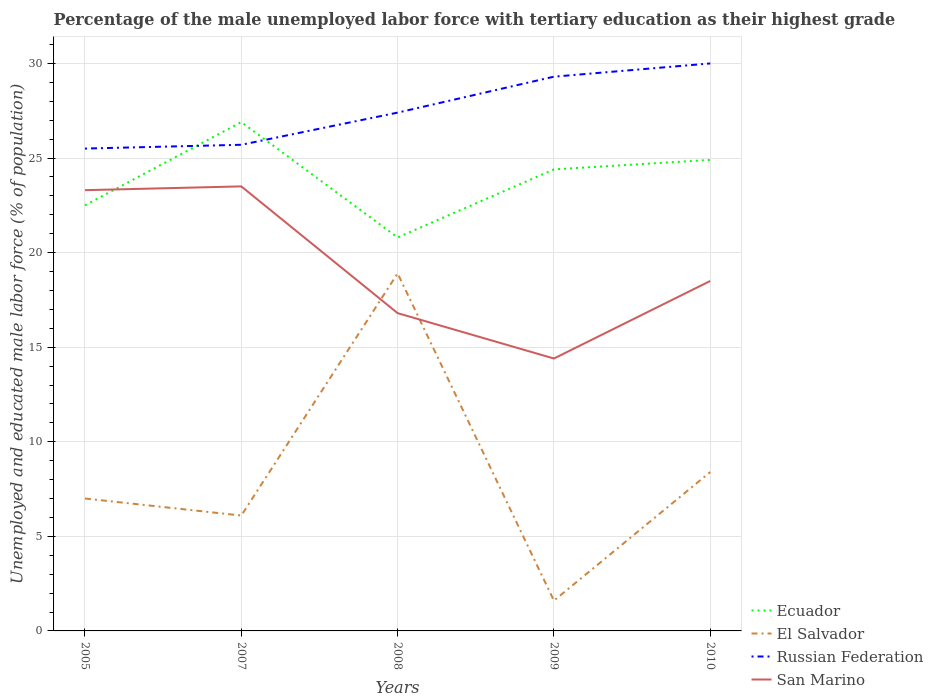How many different coloured lines are there?
Give a very brief answer. 4. Is the number of lines equal to the number of legend labels?
Your answer should be compact. Yes. Across all years, what is the maximum percentage of the unemployed male labor force with tertiary education in San Marino?
Your answer should be very brief. 14.4. In which year was the percentage of the unemployed male labor force with tertiary education in San Marino maximum?
Ensure brevity in your answer.  2009. What is the total percentage of the unemployed male labor force with tertiary education in El Salvador in the graph?
Offer a very short reply. 0.9. What is the difference between the highest and the second highest percentage of the unemployed male labor force with tertiary education in San Marino?
Ensure brevity in your answer.  9.1. What is the difference between the highest and the lowest percentage of the unemployed male labor force with tertiary education in Russian Federation?
Give a very brief answer. 2. Is the percentage of the unemployed male labor force with tertiary education in Ecuador strictly greater than the percentage of the unemployed male labor force with tertiary education in El Salvador over the years?
Your answer should be very brief. No. How many years are there in the graph?
Provide a short and direct response. 5. What is the difference between two consecutive major ticks on the Y-axis?
Make the answer very short. 5. Are the values on the major ticks of Y-axis written in scientific E-notation?
Offer a very short reply. No. What is the title of the graph?
Your answer should be compact. Percentage of the male unemployed labor force with tertiary education as their highest grade. What is the label or title of the Y-axis?
Provide a short and direct response. Unemployed and educated male labor force (% of population). What is the Unemployed and educated male labor force (% of population) in Russian Federation in 2005?
Your answer should be compact. 25.5. What is the Unemployed and educated male labor force (% of population) of San Marino in 2005?
Provide a short and direct response. 23.3. What is the Unemployed and educated male labor force (% of population) in Ecuador in 2007?
Your response must be concise. 26.9. What is the Unemployed and educated male labor force (% of population) in El Salvador in 2007?
Ensure brevity in your answer.  6.1. What is the Unemployed and educated male labor force (% of population) of Russian Federation in 2007?
Your response must be concise. 25.7. What is the Unemployed and educated male labor force (% of population) of Ecuador in 2008?
Give a very brief answer. 20.8. What is the Unemployed and educated male labor force (% of population) in El Salvador in 2008?
Offer a terse response. 18.9. What is the Unemployed and educated male labor force (% of population) in Russian Federation in 2008?
Keep it short and to the point. 27.4. What is the Unemployed and educated male labor force (% of population) in San Marino in 2008?
Your answer should be compact. 16.8. What is the Unemployed and educated male labor force (% of population) in Ecuador in 2009?
Provide a succinct answer. 24.4. What is the Unemployed and educated male labor force (% of population) of El Salvador in 2009?
Offer a very short reply. 1.6. What is the Unemployed and educated male labor force (% of population) of Russian Federation in 2009?
Offer a terse response. 29.3. What is the Unemployed and educated male labor force (% of population) of San Marino in 2009?
Offer a terse response. 14.4. What is the Unemployed and educated male labor force (% of population) of Ecuador in 2010?
Provide a short and direct response. 24.9. What is the Unemployed and educated male labor force (% of population) of El Salvador in 2010?
Your answer should be very brief. 8.4. What is the Unemployed and educated male labor force (% of population) in Russian Federation in 2010?
Give a very brief answer. 30. What is the Unemployed and educated male labor force (% of population) of San Marino in 2010?
Offer a terse response. 18.5. Across all years, what is the maximum Unemployed and educated male labor force (% of population) of Ecuador?
Your answer should be compact. 26.9. Across all years, what is the maximum Unemployed and educated male labor force (% of population) in El Salvador?
Offer a terse response. 18.9. Across all years, what is the minimum Unemployed and educated male labor force (% of population) of Ecuador?
Offer a terse response. 20.8. Across all years, what is the minimum Unemployed and educated male labor force (% of population) of El Salvador?
Offer a very short reply. 1.6. Across all years, what is the minimum Unemployed and educated male labor force (% of population) of San Marino?
Your answer should be very brief. 14.4. What is the total Unemployed and educated male labor force (% of population) of Ecuador in the graph?
Provide a succinct answer. 119.5. What is the total Unemployed and educated male labor force (% of population) in El Salvador in the graph?
Keep it short and to the point. 42. What is the total Unemployed and educated male labor force (% of population) of Russian Federation in the graph?
Keep it short and to the point. 137.9. What is the total Unemployed and educated male labor force (% of population) of San Marino in the graph?
Your answer should be compact. 96.5. What is the difference between the Unemployed and educated male labor force (% of population) of Ecuador in 2005 and that in 2008?
Provide a short and direct response. 1.7. What is the difference between the Unemployed and educated male labor force (% of population) of El Salvador in 2005 and that in 2008?
Offer a terse response. -11.9. What is the difference between the Unemployed and educated male labor force (% of population) in El Salvador in 2005 and that in 2009?
Provide a short and direct response. 5.4. What is the difference between the Unemployed and educated male labor force (% of population) in Russian Federation in 2005 and that in 2009?
Offer a very short reply. -3.8. What is the difference between the Unemployed and educated male labor force (% of population) in San Marino in 2005 and that in 2009?
Your response must be concise. 8.9. What is the difference between the Unemployed and educated male labor force (% of population) in Ecuador in 2005 and that in 2010?
Ensure brevity in your answer.  -2.4. What is the difference between the Unemployed and educated male labor force (% of population) in Russian Federation in 2005 and that in 2010?
Provide a short and direct response. -4.5. What is the difference between the Unemployed and educated male labor force (% of population) in Ecuador in 2007 and that in 2008?
Your answer should be very brief. 6.1. What is the difference between the Unemployed and educated male labor force (% of population) of El Salvador in 2007 and that in 2008?
Keep it short and to the point. -12.8. What is the difference between the Unemployed and educated male labor force (% of population) in San Marino in 2007 and that in 2008?
Provide a succinct answer. 6.7. What is the difference between the Unemployed and educated male labor force (% of population) of Ecuador in 2007 and that in 2009?
Your response must be concise. 2.5. What is the difference between the Unemployed and educated male labor force (% of population) of El Salvador in 2007 and that in 2009?
Keep it short and to the point. 4.5. What is the difference between the Unemployed and educated male labor force (% of population) of Russian Federation in 2007 and that in 2009?
Keep it short and to the point. -3.6. What is the difference between the Unemployed and educated male labor force (% of population) of Ecuador in 2007 and that in 2010?
Ensure brevity in your answer.  2. What is the difference between the Unemployed and educated male labor force (% of population) in El Salvador in 2007 and that in 2010?
Provide a short and direct response. -2.3. What is the difference between the Unemployed and educated male labor force (% of population) in Russian Federation in 2007 and that in 2010?
Give a very brief answer. -4.3. What is the difference between the Unemployed and educated male labor force (% of population) of San Marino in 2007 and that in 2010?
Offer a terse response. 5. What is the difference between the Unemployed and educated male labor force (% of population) of El Salvador in 2008 and that in 2009?
Provide a short and direct response. 17.3. What is the difference between the Unemployed and educated male labor force (% of population) in Russian Federation in 2008 and that in 2009?
Offer a terse response. -1.9. What is the difference between the Unemployed and educated male labor force (% of population) in San Marino in 2008 and that in 2009?
Give a very brief answer. 2.4. What is the difference between the Unemployed and educated male labor force (% of population) of Ecuador in 2008 and that in 2010?
Keep it short and to the point. -4.1. What is the difference between the Unemployed and educated male labor force (% of population) in San Marino in 2008 and that in 2010?
Give a very brief answer. -1.7. What is the difference between the Unemployed and educated male labor force (% of population) in San Marino in 2009 and that in 2010?
Provide a succinct answer. -4.1. What is the difference between the Unemployed and educated male labor force (% of population) of Ecuador in 2005 and the Unemployed and educated male labor force (% of population) of Russian Federation in 2007?
Ensure brevity in your answer.  -3.2. What is the difference between the Unemployed and educated male labor force (% of population) in Ecuador in 2005 and the Unemployed and educated male labor force (% of population) in San Marino in 2007?
Ensure brevity in your answer.  -1. What is the difference between the Unemployed and educated male labor force (% of population) of El Salvador in 2005 and the Unemployed and educated male labor force (% of population) of Russian Federation in 2007?
Offer a terse response. -18.7. What is the difference between the Unemployed and educated male labor force (% of population) in El Salvador in 2005 and the Unemployed and educated male labor force (% of population) in San Marino in 2007?
Provide a succinct answer. -16.5. What is the difference between the Unemployed and educated male labor force (% of population) of Ecuador in 2005 and the Unemployed and educated male labor force (% of population) of El Salvador in 2008?
Give a very brief answer. 3.6. What is the difference between the Unemployed and educated male labor force (% of population) in Ecuador in 2005 and the Unemployed and educated male labor force (% of population) in San Marino in 2008?
Provide a succinct answer. 5.7. What is the difference between the Unemployed and educated male labor force (% of population) of El Salvador in 2005 and the Unemployed and educated male labor force (% of population) of Russian Federation in 2008?
Make the answer very short. -20.4. What is the difference between the Unemployed and educated male labor force (% of population) in El Salvador in 2005 and the Unemployed and educated male labor force (% of population) in San Marino in 2008?
Your answer should be very brief. -9.8. What is the difference between the Unemployed and educated male labor force (% of population) in Russian Federation in 2005 and the Unemployed and educated male labor force (% of population) in San Marino in 2008?
Your response must be concise. 8.7. What is the difference between the Unemployed and educated male labor force (% of population) in Ecuador in 2005 and the Unemployed and educated male labor force (% of population) in El Salvador in 2009?
Give a very brief answer. 20.9. What is the difference between the Unemployed and educated male labor force (% of population) in El Salvador in 2005 and the Unemployed and educated male labor force (% of population) in Russian Federation in 2009?
Make the answer very short. -22.3. What is the difference between the Unemployed and educated male labor force (% of population) of Ecuador in 2005 and the Unemployed and educated male labor force (% of population) of El Salvador in 2010?
Your answer should be compact. 14.1. What is the difference between the Unemployed and educated male labor force (% of population) in El Salvador in 2005 and the Unemployed and educated male labor force (% of population) in San Marino in 2010?
Make the answer very short. -11.5. What is the difference between the Unemployed and educated male labor force (% of population) of Russian Federation in 2005 and the Unemployed and educated male labor force (% of population) of San Marino in 2010?
Offer a very short reply. 7. What is the difference between the Unemployed and educated male labor force (% of population) in Ecuador in 2007 and the Unemployed and educated male labor force (% of population) in San Marino in 2008?
Make the answer very short. 10.1. What is the difference between the Unemployed and educated male labor force (% of population) of El Salvador in 2007 and the Unemployed and educated male labor force (% of population) of Russian Federation in 2008?
Provide a short and direct response. -21.3. What is the difference between the Unemployed and educated male labor force (% of population) in Russian Federation in 2007 and the Unemployed and educated male labor force (% of population) in San Marino in 2008?
Give a very brief answer. 8.9. What is the difference between the Unemployed and educated male labor force (% of population) of Ecuador in 2007 and the Unemployed and educated male labor force (% of population) of El Salvador in 2009?
Ensure brevity in your answer.  25.3. What is the difference between the Unemployed and educated male labor force (% of population) of Ecuador in 2007 and the Unemployed and educated male labor force (% of population) of Russian Federation in 2009?
Offer a terse response. -2.4. What is the difference between the Unemployed and educated male labor force (% of population) of El Salvador in 2007 and the Unemployed and educated male labor force (% of population) of Russian Federation in 2009?
Keep it short and to the point. -23.2. What is the difference between the Unemployed and educated male labor force (% of population) of Ecuador in 2007 and the Unemployed and educated male labor force (% of population) of San Marino in 2010?
Your answer should be very brief. 8.4. What is the difference between the Unemployed and educated male labor force (% of population) in El Salvador in 2007 and the Unemployed and educated male labor force (% of population) in Russian Federation in 2010?
Your response must be concise. -23.9. What is the difference between the Unemployed and educated male labor force (% of population) of Russian Federation in 2007 and the Unemployed and educated male labor force (% of population) of San Marino in 2010?
Keep it short and to the point. 7.2. What is the difference between the Unemployed and educated male labor force (% of population) in Ecuador in 2008 and the Unemployed and educated male labor force (% of population) in El Salvador in 2009?
Offer a very short reply. 19.2. What is the difference between the Unemployed and educated male labor force (% of population) of Ecuador in 2008 and the Unemployed and educated male labor force (% of population) of Russian Federation in 2009?
Ensure brevity in your answer.  -8.5. What is the difference between the Unemployed and educated male labor force (% of population) of Ecuador in 2008 and the Unemployed and educated male labor force (% of population) of San Marino in 2009?
Provide a succinct answer. 6.4. What is the difference between the Unemployed and educated male labor force (% of population) of El Salvador in 2008 and the Unemployed and educated male labor force (% of population) of Russian Federation in 2009?
Keep it short and to the point. -10.4. What is the difference between the Unemployed and educated male labor force (% of population) in Russian Federation in 2008 and the Unemployed and educated male labor force (% of population) in San Marino in 2009?
Make the answer very short. 13. What is the difference between the Unemployed and educated male labor force (% of population) in Ecuador in 2008 and the Unemployed and educated male labor force (% of population) in Russian Federation in 2010?
Keep it short and to the point. -9.2. What is the difference between the Unemployed and educated male labor force (% of population) in El Salvador in 2008 and the Unemployed and educated male labor force (% of population) in Russian Federation in 2010?
Your answer should be compact. -11.1. What is the difference between the Unemployed and educated male labor force (% of population) of El Salvador in 2008 and the Unemployed and educated male labor force (% of population) of San Marino in 2010?
Make the answer very short. 0.4. What is the difference between the Unemployed and educated male labor force (% of population) of Ecuador in 2009 and the Unemployed and educated male labor force (% of population) of El Salvador in 2010?
Give a very brief answer. 16. What is the difference between the Unemployed and educated male labor force (% of population) in Ecuador in 2009 and the Unemployed and educated male labor force (% of population) in Russian Federation in 2010?
Your answer should be very brief. -5.6. What is the difference between the Unemployed and educated male labor force (% of population) in El Salvador in 2009 and the Unemployed and educated male labor force (% of population) in Russian Federation in 2010?
Provide a short and direct response. -28.4. What is the difference between the Unemployed and educated male labor force (% of population) of El Salvador in 2009 and the Unemployed and educated male labor force (% of population) of San Marino in 2010?
Offer a terse response. -16.9. What is the average Unemployed and educated male labor force (% of population) of Ecuador per year?
Give a very brief answer. 23.9. What is the average Unemployed and educated male labor force (% of population) of El Salvador per year?
Offer a very short reply. 8.4. What is the average Unemployed and educated male labor force (% of population) of Russian Federation per year?
Your answer should be very brief. 27.58. What is the average Unemployed and educated male labor force (% of population) in San Marino per year?
Provide a short and direct response. 19.3. In the year 2005, what is the difference between the Unemployed and educated male labor force (% of population) of Ecuador and Unemployed and educated male labor force (% of population) of Russian Federation?
Your response must be concise. -3. In the year 2005, what is the difference between the Unemployed and educated male labor force (% of population) in El Salvador and Unemployed and educated male labor force (% of population) in Russian Federation?
Your answer should be very brief. -18.5. In the year 2005, what is the difference between the Unemployed and educated male labor force (% of population) in El Salvador and Unemployed and educated male labor force (% of population) in San Marino?
Your response must be concise. -16.3. In the year 2005, what is the difference between the Unemployed and educated male labor force (% of population) in Russian Federation and Unemployed and educated male labor force (% of population) in San Marino?
Offer a very short reply. 2.2. In the year 2007, what is the difference between the Unemployed and educated male labor force (% of population) of Ecuador and Unemployed and educated male labor force (% of population) of El Salvador?
Give a very brief answer. 20.8. In the year 2007, what is the difference between the Unemployed and educated male labor force (% of population) of Ecuador and Unemployed and educated male labor force (% of population) of San Marino?
Your answer should be very brief. 3.4. In the year 2007, what is the difference between the Unemployed and educated male labor force (% of population) of El Salvador and Unemployed and educated male labor force (% of population) of Russian Federation?
Offer a terse response. -19.6. In the year 2007, what is the difference between the Unemployed and educated male labor force (% of population) of El Salvador and Unemployed and educated male labor force (% of population) of San Marino?
Provide a succinct answer. -17.4. In the year 2008, what is the difference between the Unemployed and educated male labor force (% of population) in Ecuador and Unemployed and educated male labor force (% of population) in Russian Federation?
Offer a terse response. -6.6. In the year 2008, what is the difference between the Unemployed and educated male labor force (% of population) of El Salvador and Unemployed and educated male labor force (% of population) of San Marino?
Provide a short and direct response. 2.1. In the year 2009, what is the difference between the Unemployed and educated male labor force (% of population) of Ecuador and Unemployed and educated male labor force (% of population) of El Salvador?
Your answer should be very brief. 22.8. In the year 2009, what is the difference between the Unemployed and educated male labor force (% of population) in Ecuador and Unemployed and educated male labor force (% of population) in Russian Federation?
Your response must be concise. -4.9. In the year 2009, what is the difference between the Unemployed and educated male labor force (% of population) of Ecuador and Unemployed and educated male labor force (% of population) of San Marino?
Make the answer very short. 10. In the year 2009, what is the difference between the Unemployed and educated male labor force (% of population) in El Salvador and Unemployed and educated male labor force (% of population) in Russian Federation?
Offer a very short reply. -27.7. In the year 2010, what is the difference between the Unemployed and educated male labor force (% of population) of Ecuador and Unemployed and educated male labor force (% of population) of Russian Federation?
Your answer should be compact. -5.1. In the year 2010, what is the difference between the Unemployed and educated male labor force (% of population) of Ecuador and Unemployed and educated male labor force (% of population) of San Marino?
Offer a terse response. 6.4. In the year 2010, what is the difference between the Unemployed and educated male labor force (% of population) in El Salvador and Unemployed and educated male labor force (% of population) in Russian Federation?
Keep it short and to the point. -21.6. In the year 2010, what is the difference between the Unemployed and educated male labor force (% of population) of Russian Federation and Unemployed and educated male labor force (% of population) of San Marino?
Offer a very short reply. 11.5. What is the ratio of the Unemployed and educated male labor force (% of population) of Ecuador in 2005 to that in 2007?
Your response must be concise. 0.84. What is the ratio of the Unemployed and educated male labor force (% of population) in El Salvador in 2005 to that in 2007?
Your response must be concise. 1.15. What is the ratio of the Unemployed and educated male labor force (% of population) in Ecuador in 2005 to that in 2008?
Offer a terse response. 1.08. What is the ratio of the Unemployed and educated male labor force (% of population) in El Salvador in 2005 to that in 2008?
Provide a short and direct response. 0.37. What is the ratio of the Unemployed and educated male labor force (% of population) of Russian Federation in 2005 to that in 2008?
Provide a succinct answer. 0.93. What is the ratio of the Unemployed and educated male labor force (% of population) in San Marino in 2005 to that in 2008?
Your answer should be compact. 1.39. What is the ratio of the Unemployed and educated male labor force (% of population) of Ecuador in 2005 to that in 2009?
Provide a succinct answer. 0.92. What is the ratio of the Unemployed and educated male labor force (% of population) of El Salvador in 2005 to that in 2009?
Ensure brevity in your answer.  4.38. What is the ratio of the Unemployed and educated male labor force (% of population) of Russian Federation in 2005 to that in 2009?
Your answer should be compact. 0.87. What is the ratio of the Unemployed and educated male labor force (% of population) of San Marino in 2005 to that in 2009?
Your answer should be compact. 1.62. What is the ratio of the Unemployed and educated male labor force (% of population) in Ecuador in 2005 to that in 2010?
Ensure brevity in your answer.  0.9. What is the ratio of the Unemployed and educated male labor force (% of population) in El Salvador in 2005 to that in 2010?
Give a very brief answer. 0.83. What is the ratio of the Unemployed and educated male labor force (% of population) in Russian Federation in 2005 to that in 2010?
Your answer should be compact. 0.85. What is the ratio of the Unemployed and educated male labor force (% of population) in San Marino in 2005 to that in 2010?
Offer a terse response. 1.26. What is the ratio of the Unemployed and educated male labor force (% of population) in Ecuador in 2007 to that in 2008?
Offer a very short reply. 1.29. What is the ratio of the Unemployed and educated male labor force (% of population) in El Salvador in 2007 to that in 2008?
Offer a very short reply. 0.32. What is the ratio of the Unemployed and educated male labor force (% of population) in Russian Federation in 2007 to that in 2008?
Offer a very short reply. 0.94. What is the ratio of the Unemployed and educated male labor force (% of population) of San Marino in 2007 to that in 2008?
Offer a very short reply. 1.4. What is the ratio of the Unemployed and educated male labor force (% of population) in Ecuador in 2007 to that in 2009?
Keep it short and to the point. 1.1. What is the ratio of the Unemployed and educated male labor force (% of population) in El Salvador in 2007 to that in 2009?
Your response must be concise. 3.81. What is the ratio of the Unemployed and educated male labor force (% of population) in Russian Federation in 2007 to that in 2009?
Your response must be concise. 0.88. What is the ratio of the Unemployed and educated male labor force (% of population) of San Marino in 2007 to that in 2009?
Ensure brevity in your answer.  1.63. What is the ratio of the Unemployed and educated male labor force (% of population) of Ecuador in 2007 to that in 2010?
Ensure brevity in your answer.  1.08. What is the ratio of the Unemployed and educated male labor force (% of population) in El Salvador in 2007 to that in 2010?
Ensure brevity in your answer.  0.73. What is the ratio of the Unemployed and educated male labor force (% of population) in Russian Federation in 2007 to that in 2010?
Provide a short and direct response. 0.86. What is the ratio of the Unemployed and educated male labor force (% of population) of San Marino in 2007 to that in 2010?
Your response must be concise. 1.27. What is the ratio of the Unemployed and educated male labor force (% of population) of Ecuador in 2008 to that in 2009?
Your response must be concise. 0.85. What is the ratio of the Unemployed and educated male labor force (% of population) of El Salvador in 2008 to that in 2009?
Make the answer very short. 11.81. What is the ratio of the Unemployed and educated male labor force (% of population) of Russian Federation in 2008 to that in 2009?
Your answer should be very brief. 0.94. What is the ratio of the Unemployed and educated male labor force (% of population) of San Marino in 2008 to that in 2009?
Provide a short and direct response. 1.17. What is the ratio of the Unemployed and educated male labor force (% of population) in Ecuador in 2008 to that in 2010?
Keep it short and to the point. 0.84. What is the ratio of the Unemployed and educated male labor force (% of population) in El Salvador in 2008 to that in 2010?
Ensure brevity in your answer.  2.25. What is the ratio of the Unemployed and educated male labor force (% of population) in Russian Federation in 2008 to that in 2010?
Give a very brief answer. 0.91. What is the ratio of the Unemployed and educated male labor force (% of population) of San Marino in 2008 to that in 2010?
Make the answer very short. 0.91. What is the ratio of the Unemployed and educated male labor force (% of population) in Ecuador in 2009 to that in 2010?
Keep it short and to the point. 0.98. What is the ratio of the Unemployed and educated male labor force (% of population) in El Salvador in 2009 to that in 2010?
Offer a terse response. 0.19. What is the ratio of the Unemployed and educated male labor force (% of population) of Russian Federation in 2009 to that in 2010?
Offer a terse response. 0.98. What is the ratio of the Unemployed and educated male labor force (% of population) of San Marino in 2009 to that in 2010?
Keep it short and to the point. 0.78. What is the difference between the highest and the lowest Unemployed and educated male labor force (% of population) in Ecuador?
Your answer should be compact. 6.1. What is the difference between the highest and the lowest Unemployed and educated male labor force (% of population) in El Salvador?
Offer a very short reply. 17.3. What is the difference between the highest and the lowest Unemployed and educated male labor force (% of population) in San Marino?
Offer a terse response. 9.1. 